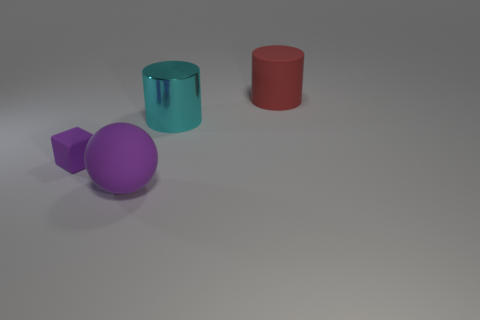Is there another purple thing of the same shape as the small purple matte object?
Make the answer very short. No. What is the size of the ball that is on the left side of the big red rubber cylinder?
Your answer should be very brief. Large. What is the material of the other cylinder that is the same size as the red rubber cylinder?
Keep it short and to the point. Metal. Is the number of big spheres greater than the number of gray metallic blocks?
Offer a very short reply. Yes. There is a purple rubber thing in front of the purple rubber object that is behind the big purple rubber ball; how big is it?
Make the answer very short. Large. What is the shape of the metallic object that is the same size as the ball?
Provide a short and direct response. Cylinder. There is a large rubber object on the right side of the big purple thing that is in front of the cylinder that is behind the cyan shiny object; what is its shape?
Ensure brevity in your answer.  Cylinder. There is a object on the right side of the big cyan metallic cylinder; is it the same color as the large matte thing in front of the red thing?
Provide a short and direct response. No. How many yellow matte spheres are there?
Your answer should be compact. 0. Are there any purple blocks on the right side of the tiny rubber cube?
Your answer should be compact. No. 